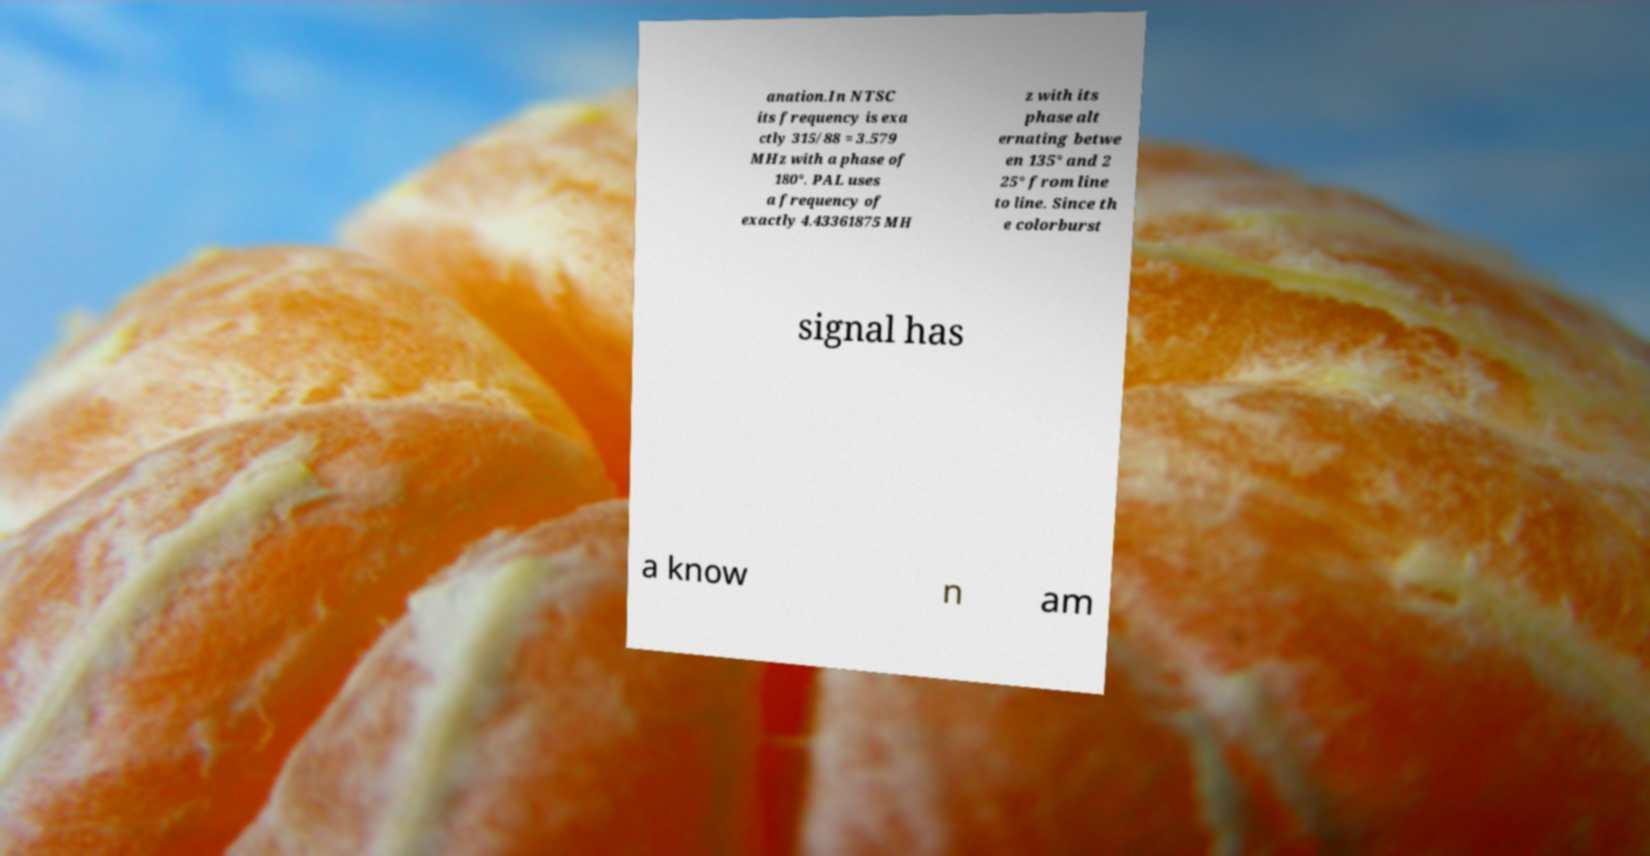Can you accurately transcribe the text from the provided image for me? anation.In NTSC its frequency is exa ctly 315/88 = 3.579 MHz with a phase of 180°. PAL uses a frequency of exactly 4.43361875 MH z with its phase alt ernating betwe en 135° and 2 25° from line to line. Since th e colorburst signal has a know n am 